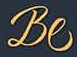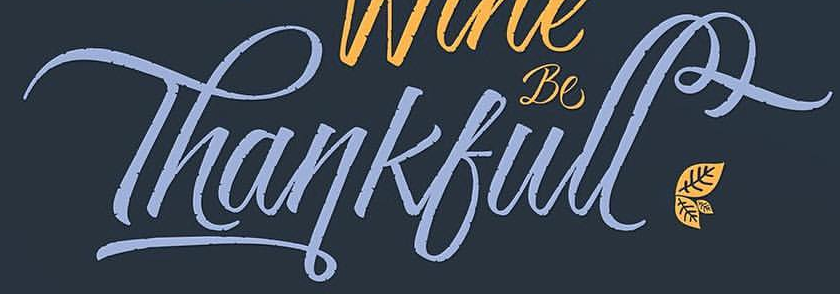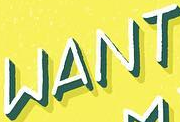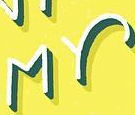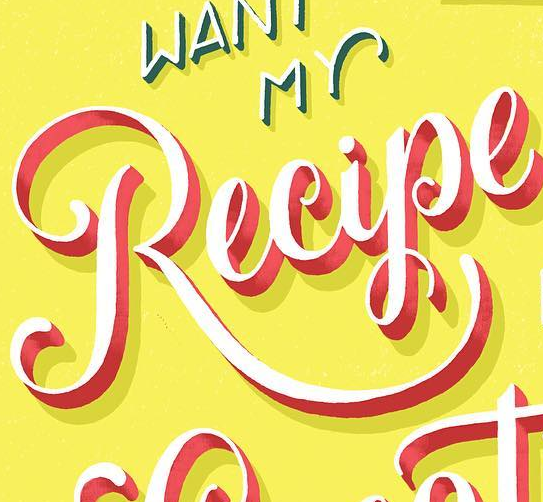Read the text from these images in sequence, separated by a semicolon. Be; Thankfull; WANT; MY; Recipe 